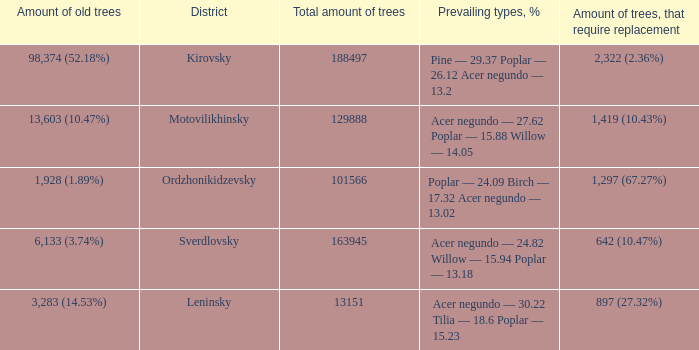What is the district when prevailing types, % is acer negundo — 30.22 tilia — 18.6 poplar — 15.23? Leninsky. 